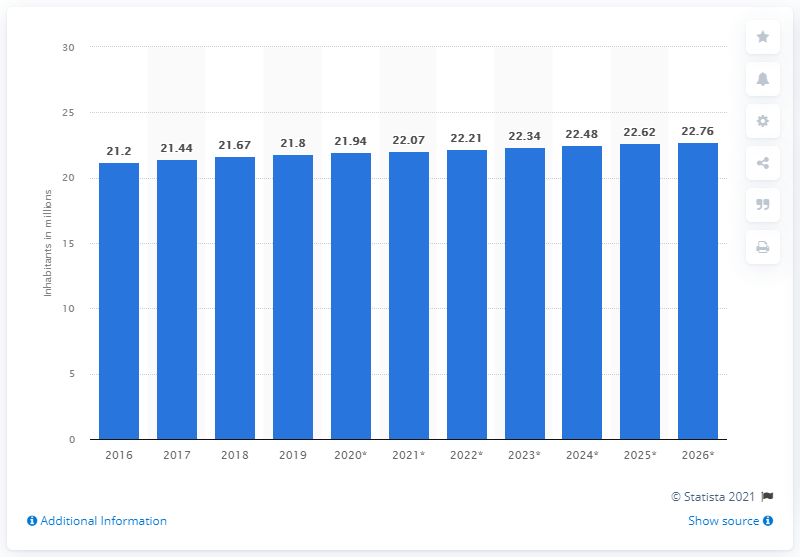Outline some significant characteristics in this image. According to available data, the population of Sri Lanka in 2019 was approximately 21.94 million. 